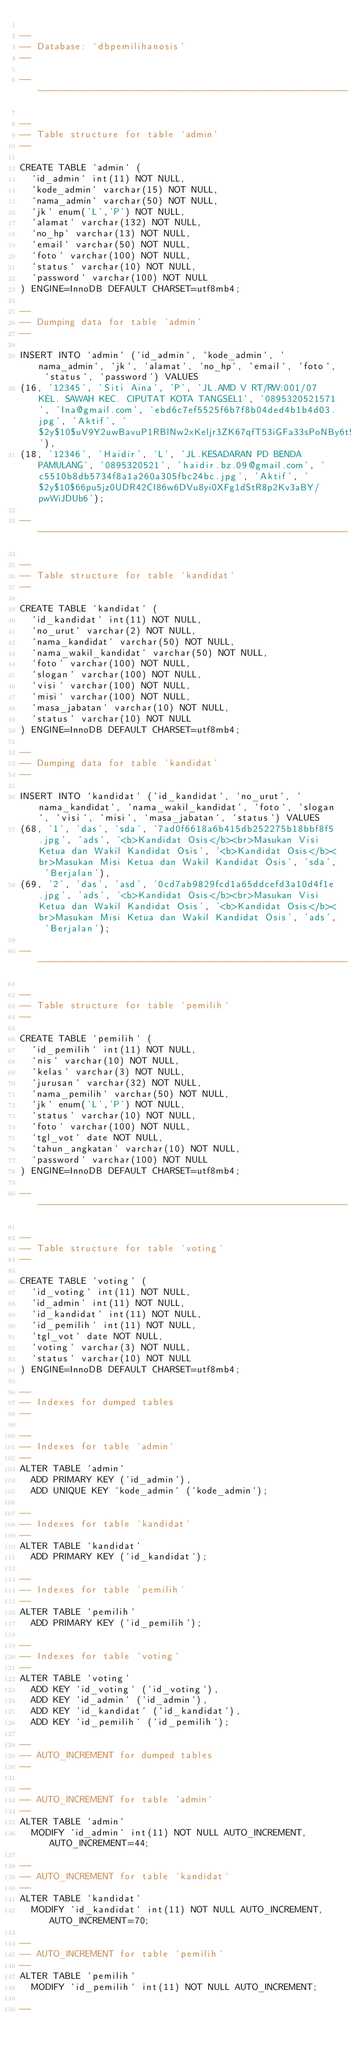Convert code to text. <code><loc_0><loc_0><loc_500><loc_500><_SQL_>
--
-- Database: `dbpemilihanosis`
--

-- --------------------------------------------------------

--
-- Table structure for table `admin`
--

CREATE TABLE `admin` (
  `id_admin` int(11) NOT NULL,
  `kode_admin` varchar(15) NOT NULL,
  `nama_admin` varchar(50) NOT NULL,
  `jk` enum('L','P') NOT NULL,
  `alamat` varchar(132) NOT NULL,
  `no_hp` varchar(13) NOT NULL,
  `email` varchar(50) NOT NULL,
  `foto` varchar(100) NOT NULL,
  `status` varchar(10) NOT NULL,
  `password` varchar(100) NOT NULL
) ENGINE=InnoDB DEFAULT CHARSET=utf8mb4;

--
-- Dumping data for table `admin`
--

INSERT INTO `admin` (`id_admin`, `kode_admin`, `nama_admin`, `jk`, `alamat`, `no_hp`, `email`, `foto`, `status`, `password`) VALUES
(16, '12345', 'Siti Aina', 'P', 'JL.AMD V RT/RW:001/07 KEL. SAWAH KEC. CIPUTAT KOTA TANGSEL1', '0895320521571', 'Ina@gmail.com', 'ebd6c7ef5525f6b7f8b04ded4b1b4d03.jpg', 'Aktif', '$2y$10$uV9Y2uwBavuP1RBlNw2xKeljr3ZK67qfT53iGFa33sPoNBy6t5r86'),
(18, '12346', 'Haidir', 'L', 'JL.KESADARAN PD BENDA PAMULANG', '0895320521', 'haidir.bz.09@gmail.com', 'c5510b8db5734f8a1a260a305fbc24bc.jpg', 'Aktif', '$2y$10$66pu5jz0UDR42CI86w6DVu8yi0XFg1dStR8p2Kv3aBY/pwWiJDUb6');

-- --------------------------------------------------------

--
-- Table structure for table `kandidat`
--

CREATE TABLE `kandidat` (
  `id_kandidat` int(11) NOT NULL,
  `no_urut` varchar(2) NOT NULL,
  `nama_kandidat` varchar(50) NOT NULL,
  `nama_wakil_kandidat` varchar(50) NOT NULL,
  `foto` varchar(100) NOT NULL,
  `slogan` varchar(100) NOT NULL,
  `visi` varchar(100) NOT NULL,
  `misi` varchar(100) NOT NULL,
  `masa_jabatan` varchar(10) NOT NULL,
  `status` varchar(10) NOT NULL
) ENGINE=InnoDB DEFAULT CHARSET=utf8mb4;

--
-- Dumping data for table `kandidat`
--

INSERT INTO `kandidat` (`id_kandidat`, `no_urut`, `nama_kandidat`, `nama_wakil_kandidat`, `foto`, `slogan`, `visi`, `misi`, `masa_jabatan`, `status`) VALUES
(68, '1', 'das', 'sda', '7ad0f6618a6b415db252275b18bbf8f5.jpg', 'ads', '<b>Kandidat Osis</b><br>Masukan Visi Ketua dan Wakil Kandidat Osis', '<b>Kandidat Osis</b><br>Masukan Misi Ketua dan Wakil Kandidat Osis', 'sda', 'Berjalan'),
(69, '2', 'das', 'asd', '0cd7ab9829fcd1a65ddcefd3a10d4f1e.jpg', 'ads', '<b>Kandidat Osis</b><br>Masukan Visi Ketua dan Wakil Kandidat Osis', '<b>Kandidat Osis</b><br>Masukan Misi Ketua dan Wakil Kandidat Osis', 'ads', 'Berjalan');

-- --------------------------------------------------------

--
-- Table structure for table `pemilih`
--

CREATE TABLE `pemilih` (
  `id_pemilih` int(11) NOT NULL,
  `nis` varchar(10) NOT NULL,
  `kelas` varchar(3) NOT NULL,
  `jurusan` varchar(32) NOT NULL,
  `nama_pemilih` varchar(50) NOT NULL,
  `jk` enum('L','P') NOT NULL,
  `status` varchar(10) NOT NULL,
  `foto` varchar(100) NOT NULL,
  `tgl_vot` date NOT NULL,
  `tahun_angkatan` varchar(10) NOT NULL,
  `password` varchar(100) NOT NULL
) ENGINE=InnoDB DEFAULT CHARSET=utf8mb4;

-- --------------------------------------------------------

--
-- Table structure for table `voting`
--

CREATE TABLE `voting` (
  `id_voting` int(11) NOT NULL,
  `id_admin` int(11) NOT NULL,
  `id_kandidat` int(11) NOT NULL,
  `id_pemilih` int(11) NOT NULL,
  `tgl_vot` date NOT NULL,
  `voting` varchar(3) NOT NULL,
  `status` varchar(10) NOT NULL
) ENGINE=InnoDB DEFAULT CHARSET=utf8mb4;

--
-- Indexes for dumped tables
--

--
-- Indexes for table `admin`
--
ALTER TABLE `admin`
  ADD PRIMARY KEY (`id_admin`),
  ADD UNIQUE KEY `kode_admin` (`kode_admin`);

--
-- Indexes for table `kandidat`
--
ALTER TABLE `kandidat`
  ADD PRIMARY KEY (`id_kandidat`);

--
-- Indexes for table `pemilih`
--
ALTER TABLE `pemilih`
  ADD PRIMARY KEY (`id_pemilih`);

--
-- Indexes for table `voting`
--
ALTER TABLE `voting`
  ADD KEY `id_voting` (`id_voting`),
  ADD KEY `id_admin` (`id_admin`),
  ADD KEY `id_kandidat` (`id_kandidat`),
  ADD KEY `id_pemilih` (`id_pemilih`);

--
-- AUTO_INCREMENT for dumped tables
--

--
-- AUTO_INCREMENT for table `admin`
--
ALTER TABLE `admin`
  MODIFY `id_admin` int(11) NOT NULL AUTO_INCREMENT, AUTO_INCREMENT=44;

--
-- AUTO_INCREMENT for table `kandidat`
--
ALTER TABLE `kandidat`
  MODIFY `id_kandidat` int(11) NOT NULL AUTO_INCREMENT, AUTO_INCREMENT=70;

--
-- AUTO_INCREMENT for table `pemilih`
--
ALTER TABLE `pemilih`
  MODIFY `id_pemilih` int(11) NOT NULL AUTO_INCREMENT;

--</code> 